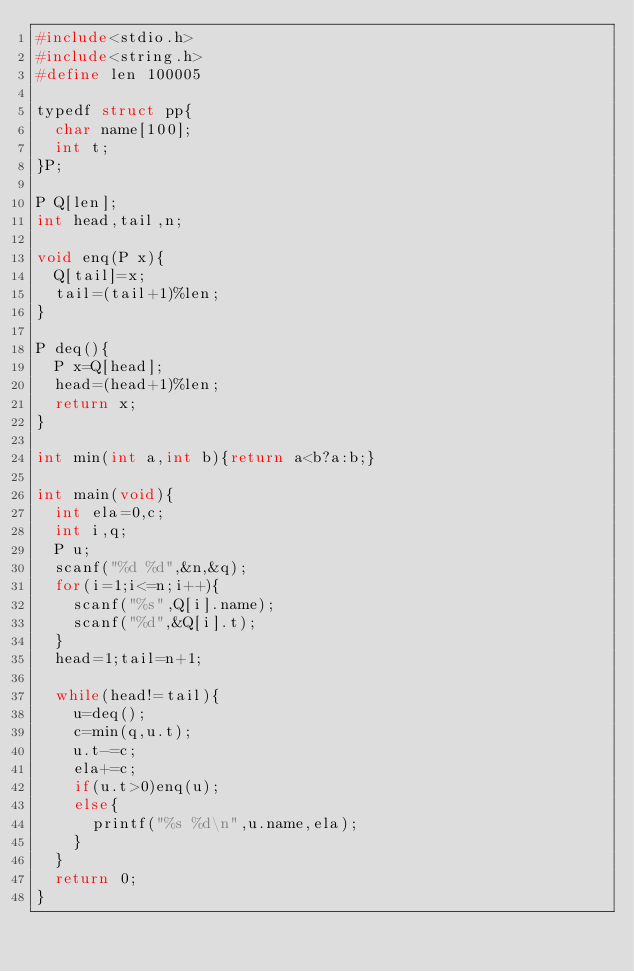<code> <loc_0><loc_0><loc_500><loc_500><_C_>#include<stdio.h>
#include<string.h>
#define len 100005

typedf struct pp{
	char name[100];
	int t;
}P;

P Q[len];
int head,tail,n;

void enq(P x){
	Q[tail]=x;
	tail=(tail+1)%len;
}

P deq(){
	P x=Q[head];
	head=(head+1)%len;
	return x;
}

int min(int a,int b){return a<b?a:b;}

int main(void){
	int ela=0,c;
	int i,q;
	P u;
	scanf("%d %d",&n,&q);
	for(i=1;i<=n;i++){
		scanf("%s",Q[i].name);
		scanf("%d",&Q[i].t);
	}
	head=1;tail=n+1;
	
	while(head!=tail){
		u=deq();
		c=min(q,u.t);
		u.t-=c;
		ela+=c;
		if(u.t>0)enq(u);
		else{
			printf("%s %d\n",u.name,ela);
		}
	}
	return 0;
}
</code> 